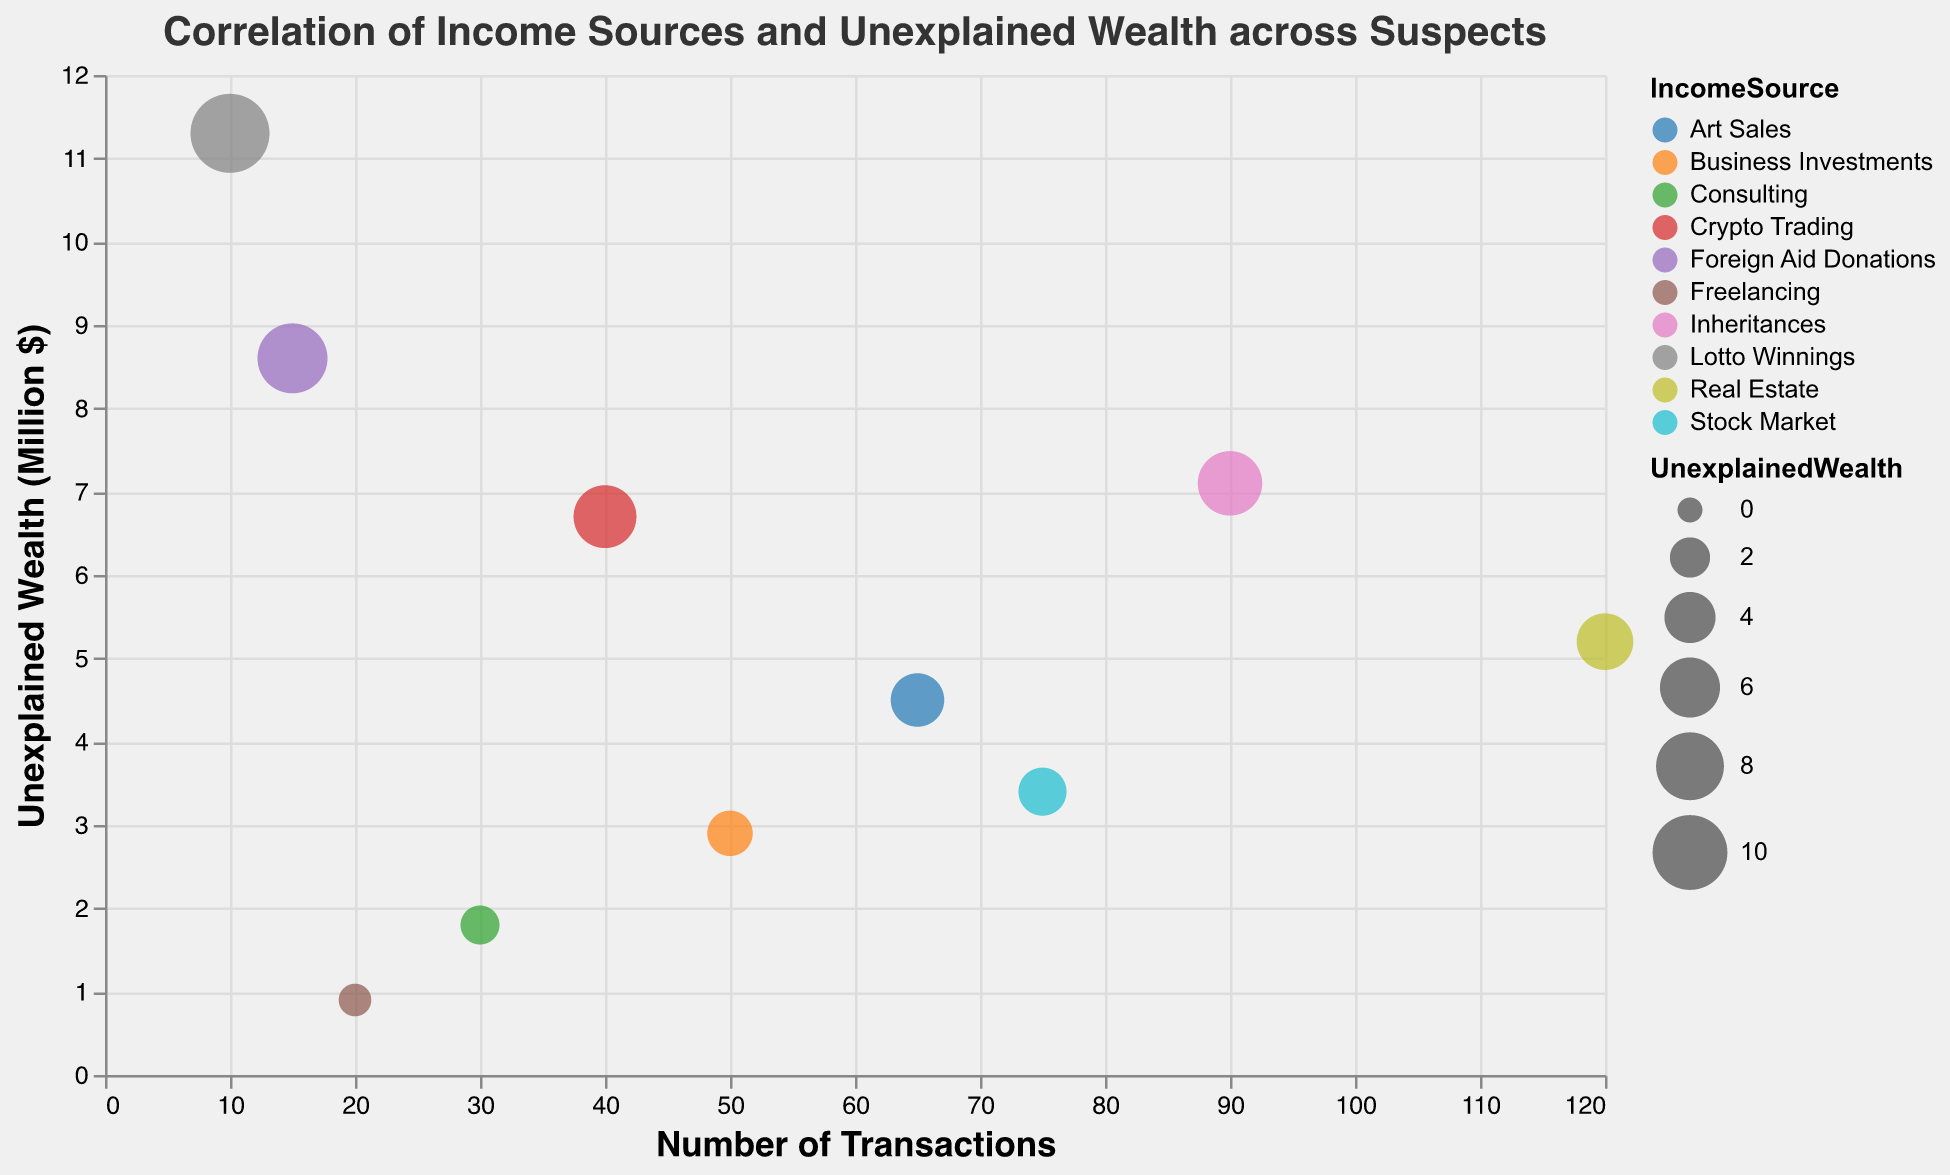What is the title of the chart? The title of the chart is usually located at the top of the figure and in this case it reads "Correlation of Income Sources and Unexplained Wealth across Suspects"
Answer: Correlation of Income Sources and Unexplained Wealth across Suspects How many suspects are represented in the chart? Each bubble in the chart represents a suspect. By counting all the bubbles, we find there are 10 suspects represented.
Answer: 10 Which Income Source has the highest Unexplained Wealth? By looking at the y-axis and finding the highest bubble, we see that "Lotto Winnings" has the highest unexplained wealth at 11.3 million dollars.
Answer: Lotto Winnings Which suspect has made the most number of transactions? The x-axis represents the number of transactions. By checking the bubbles furthest to the right, "John Doe" with Real Estate income source has made the most transactions, which is 120.
Answer: John Doe What is the Income Source of the suspect with the lowest Unexplained Wealth? To determine the lowest unexplained wealth, we look at the smallest value on the y-axis, which corresponds to "James Anderson" with Income Source of "Freelancing".
Answer: Freelancing What is the difference in Unexplained Wealth between the suspect with the highest and the lowest values? The highest unexplained wealth is 11.3 (William Johnson) and the lowest is 0.9 (James Anderson). The difference is 11.3 - 0.9 = 10.4 million dollars.
Answer: 10.4 million dollars Which suspect engaging in "Crypto Trading" has Unexplained Wealth, and how many transactions have they made? By finding "Crypto Trading" color and looking into the tooltip for that specific bubble, "Robert Wilson" has an unexplained wealth of 6.7 million dollars and has made 40 transactions.
Answer: Robert Wilson, 40 transactions Out of "Inheritances" and "Art Sales", which income source has a higher number of transactions, and what is the difference? We compare the NumberOfTransactions for Michael Brown (Inheritances, 90) and Linda Martinez (Art Sales, 65). The difference is 90 - 65 = 25 transactions.
Answer: Inheritances, 25 transactions What is the average unexplained wealth among all suspects? Sum all unexplained wealth values: 5.2 + 3.4 + 7.1 + 2.9 + 11.3 + 4.5 + 6.7 + 1.8 + 0.9 + 8.6 = 52.4 million dollars, and divide by the number of suspects (10). The average is 52.4 / 10 = 5.24 million dollars.
Answer: 5.24 million dollars How many suspects have an Unexplained Wealth greater than 6 million dollars? By examining the y-axis, we identify 4 suspects: Michael Brown (7.1), Robert Wilson (6.7), Patricia Thomas (8.6), and William Johnson (11.3).
Answer: 4 